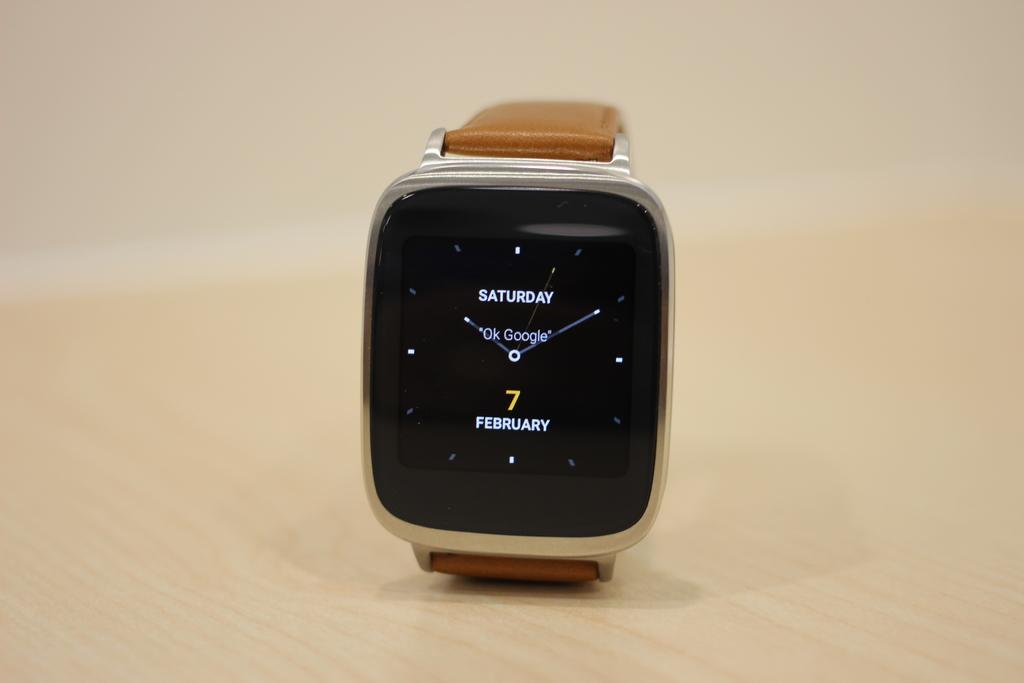<image>
Present a compact description of the photo's key features. A smart watch says that today is Saturday, the 7th of February. 